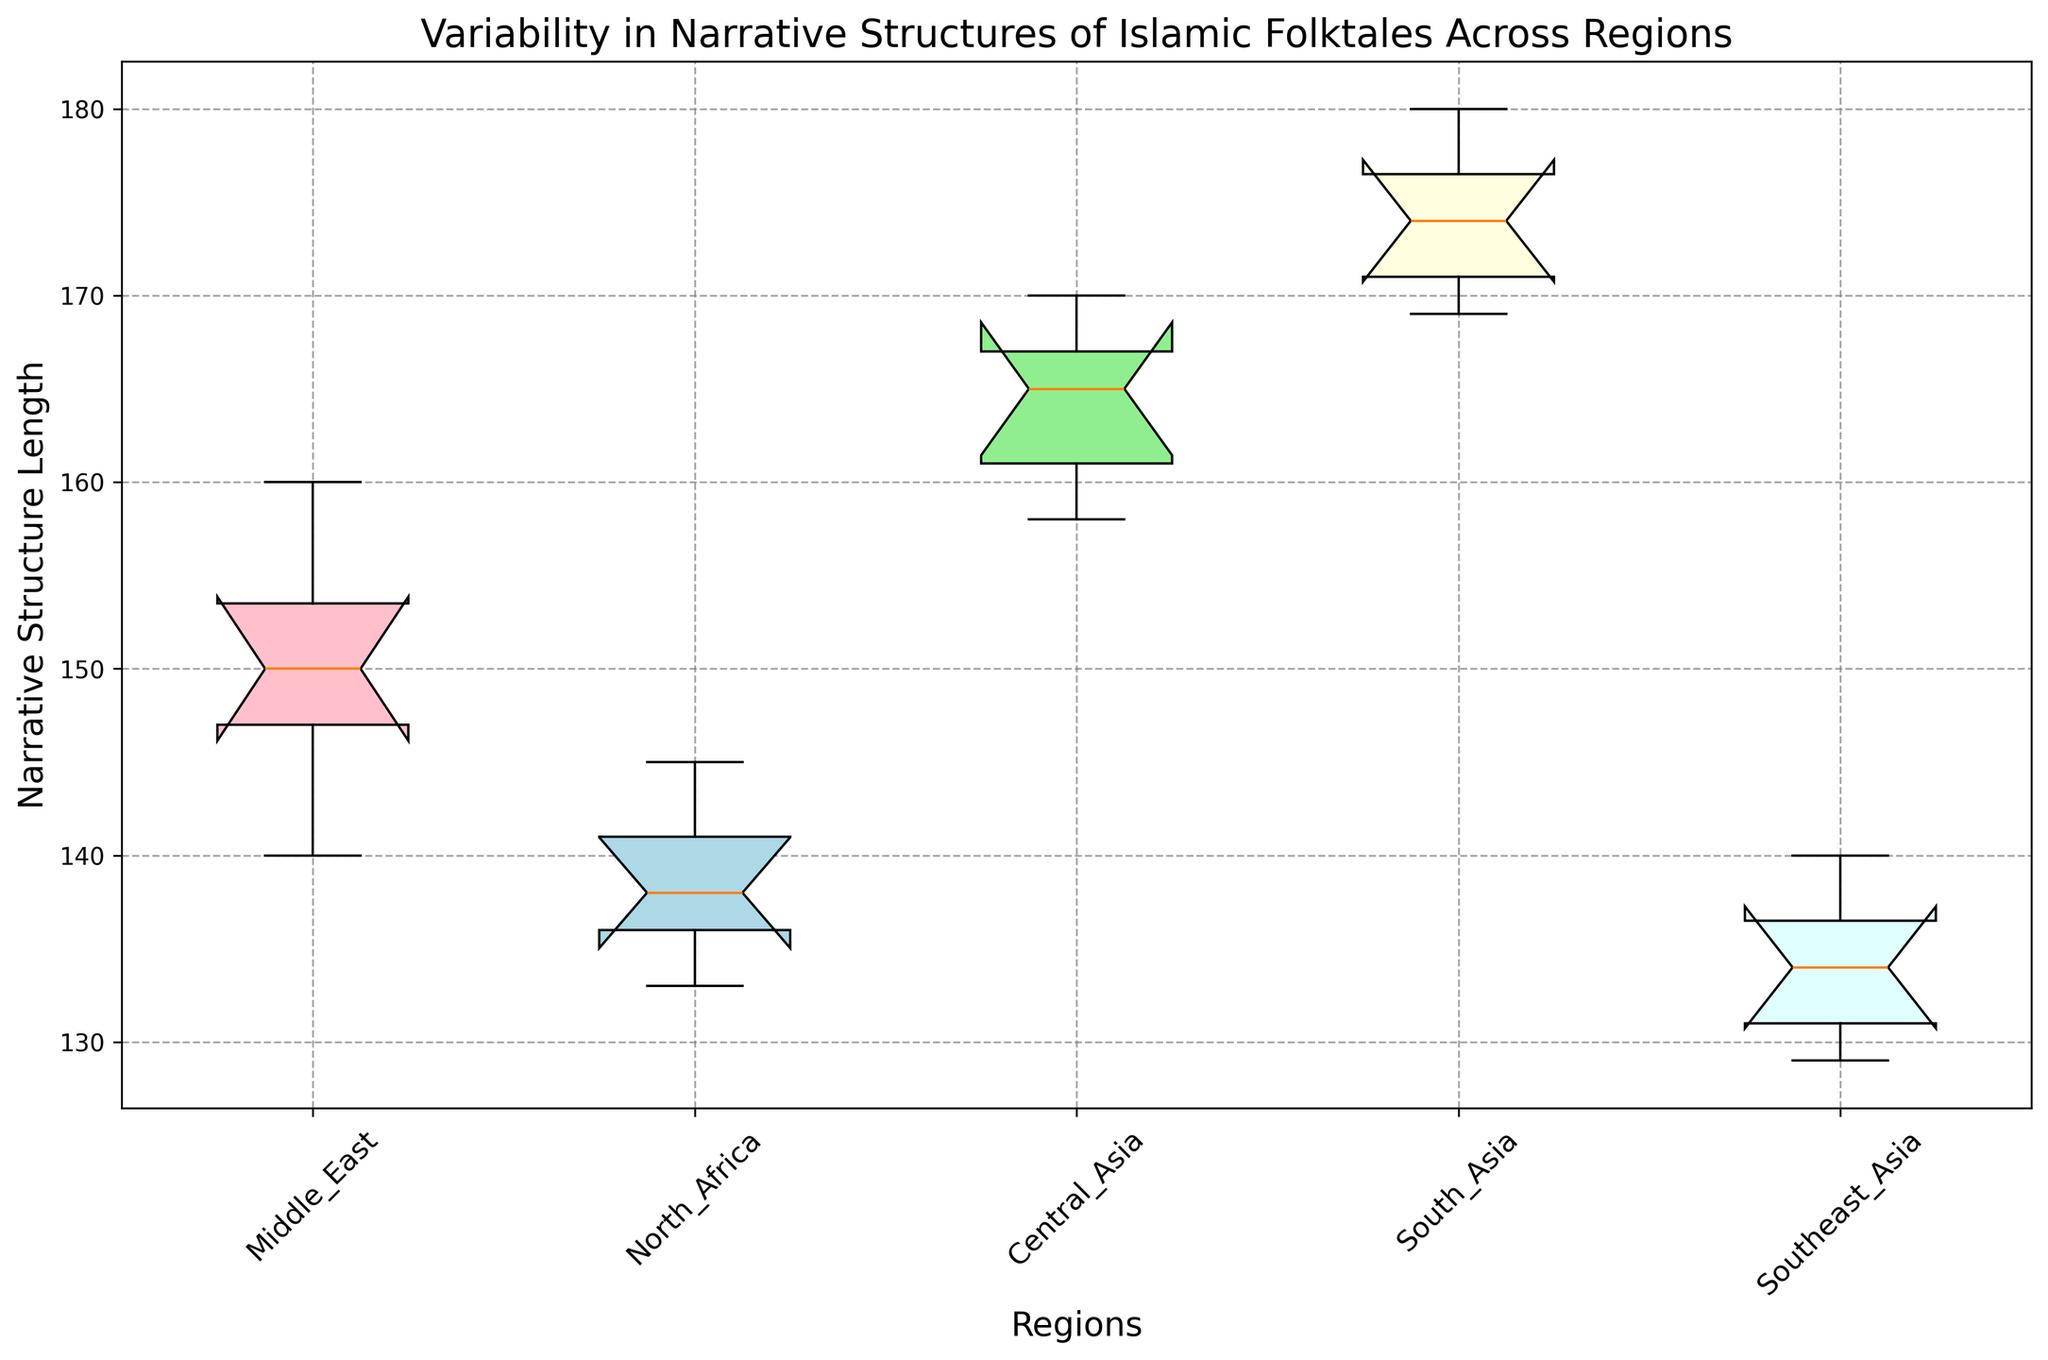What region has the highest median value for the narrative structure length? To determine the region with the highest median value, locate the middle line inside each box. The median for South Asia appears the highest among all the regions.
Answer: South Asia Which region displays the most variability in narrative structure length? The variability is indicated by the height of the box and the length of the whiskers. Central Asia has the highest range from the minimum to maximum values and a relatively tall box.
Answer: Central Asia Which regions have overlapping interquartile ranges (IQRs)? To identify overlapping IQRs, compare the height and position of the boxes. The IQRs for Middle East and Central Asia overlap, as do North Africa and Southeast Asia.
Answer: Middle East and Central Asia; North Africa and Southeast Asia What is the approximate range of narrative structure lengths for North Africa? The range is determined by the length of the whiskers. For North Africa, the minimum is around 133 and the maximum is around 145.
Answer: 133 to 145 Which region has the shortest narrative structure length? Look for the lowest point on the plot. Southeast Asia has the shortest length around 129.
Answer: Southeast Asia Is the interquartile range (IQR) of Southeast Asia's narrative structure length smaller than that of Middle East? Compare the heights of the boxes. Southeast Asia's IQR is smaller, with a more compact box.
Answer: Yes Which color corresponds to South Asia in the box plot? Observe the color used for the South Asia box. It is lightyellow.
Answer: Lightyellow Which region has the lowest minimum value for narrative structure length? Find the lowest whisker tip. Southeast Asia has the lowest minimum value around 129.
Answer: Southeast Asia How does the median narrative structure length of North Africa compare to the Middle East? Compare the middle lines (medians) in the boxes for North Africa and Middle East. North Africa's median is lower than the Middle East's.
Answer: North Africa's is lower What is the difference between the maximum narrative structure lengths for South Asia and North Africa? Compare the top whiskers of South Asia and North Africa. South Asia's maximum is around 180, and North Africa's is around 145, so the difference is 180 - 145.
Answer: 35 